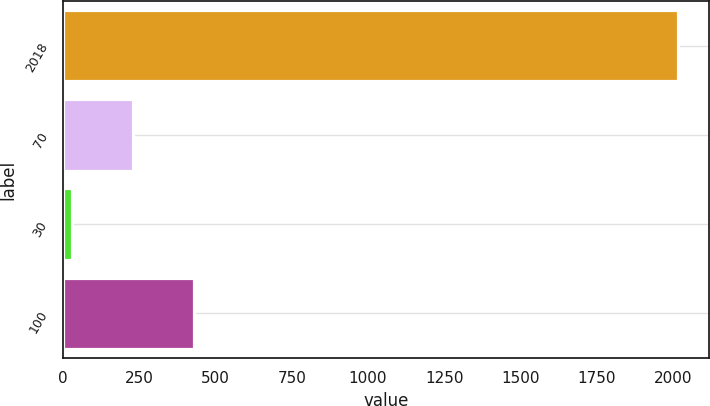Convert chart. <chart><loc_0><loc_0><loc_500><loc_500><bar_chart><fcel>2018<fcel>70<fcel>30<fcel>100<nl><fcel>2017<fcel>228.7<fcel>30<fcel>427.4<nl></chart> 